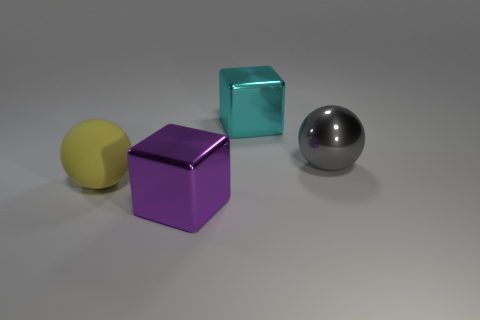Add 1 large gray metallic balls. How many objects exist? 5 Subtract all cyan blocks. How many blocks are left? 1 Subtract all cyan spheres. Subtract all red cylinders. How many spheres are left? 2 Subtract all purple cylinders. How many purple blocks are left? 1 Subtract all large green metal cubes. Subtract all cubes. How many objects are left? 2 Add 4 large metallic blocks. How many large metallic blocks are left? 6 Add 3 gray metal objects. How many gray metal objects exist? 4 Subtract 0 gray cubes. How many objects are left? 4 Subtract 2 balls. How many balls are left? 0 